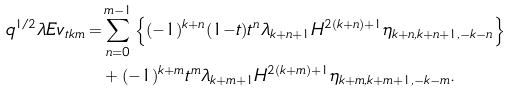Convert formula to latex. <formula><loc_0><loc_0><loc_500><loc_500>q ^ { 1 / 2 } \lambda E v _ { t k m } = & \sum ^ { m - 1 } _ { n = 0 } \left \{ ( { - } 1 ) ^ { k + n } ( 1 { - } t ) t ^ { n } \lambda _ { k + n + 1 } H ^ { 2 ( k + n ) + 1 } \eta _ { k + n , k + n + 1 , - k - n } \right \} \\ & + ( - 1 ) ^ { k + m } t ^ { m } \lambda _ { k + m + 1 } H ^ { 2 ( k + m ) + 1 } \eta _ { k + m , k + m + 1 , - k - m } .</formula> 